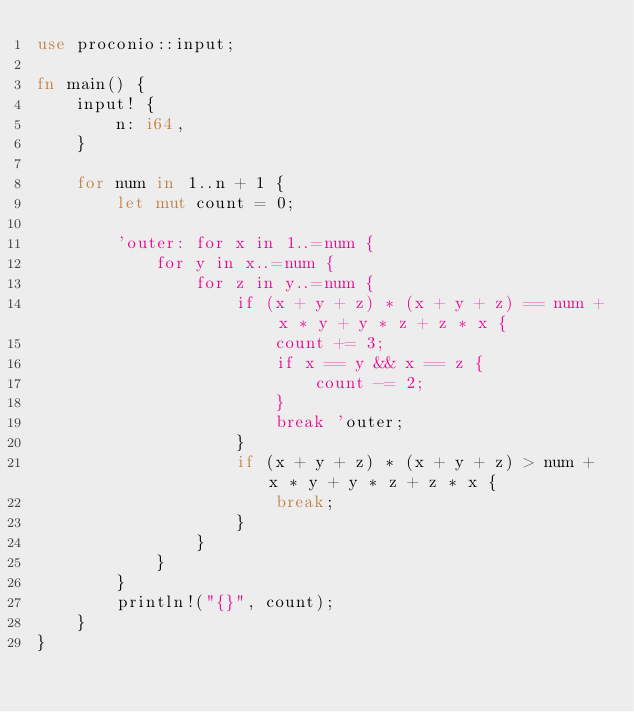Convert code to text. <code><loc_0><loc_0><loc_500><loc_500><_Rust_>use proconio::input;

fn main() {
    input! {
        n: i64,
    }

    for num in 1..n + 1 {
        let mut count = 0;

        'outer: for x in 1..=num {
            for y in x..=num {
                for z in y..=num {
                    if (x + y + z) * (x + y + z) == num + x * y + y * z + z * x {
                        count += 3;
                        if x == y && x == z {
                            count -= 2;
                        }
                        break 'outer;
                    }
                    if (x + y + z) * (x + y + z) > num + x * y + y * z + z * x {
                        break;
                    }
                }
            }
        }
        println!("{}", count);
    }
}</code> 